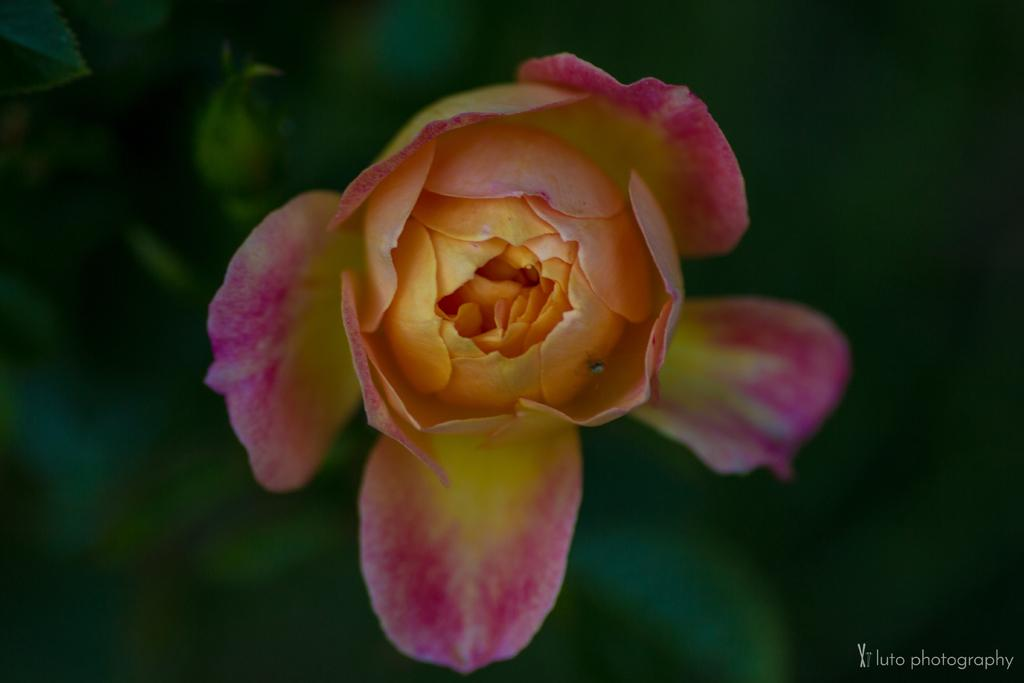What type of flower is featured in the image? There is a pink and yellow flower in the image. What can be seen in the background of the image? The background is green and blurred. Is there any text or logo visible in the image? Yes, there is a watermark in the right bottom corner of the image. How many cushions are placed on the flower in the image? There are no cushions present in the image; it features a flower and a blurred green background. 